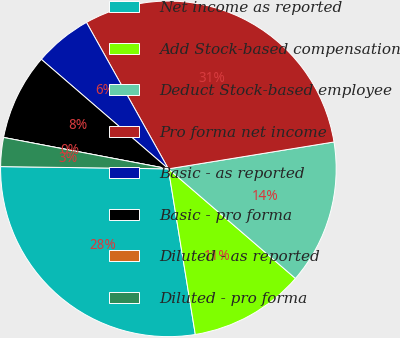Convert chart to OTSL. <chart><loc_0><loc_0><loc_500><loc_500><pie_chart><fcel>Net income as reported<fcel>Add Stock-based compensation<fcel>Deduct Stock-based employee<fcel>Pro forma net income<fcel>Basic - as reported<fcel>Basic - pro forma<fcel>Diluted - as reported<fcel>Diluted - pro forma<nl><fcel>27.78%<fcel>11.11%<fcel>13.89%<fcel>30.56%<fcel>5.56%<fcel>8.33%<fcel>0.0%<fcel>2.78%<nl></chart> 